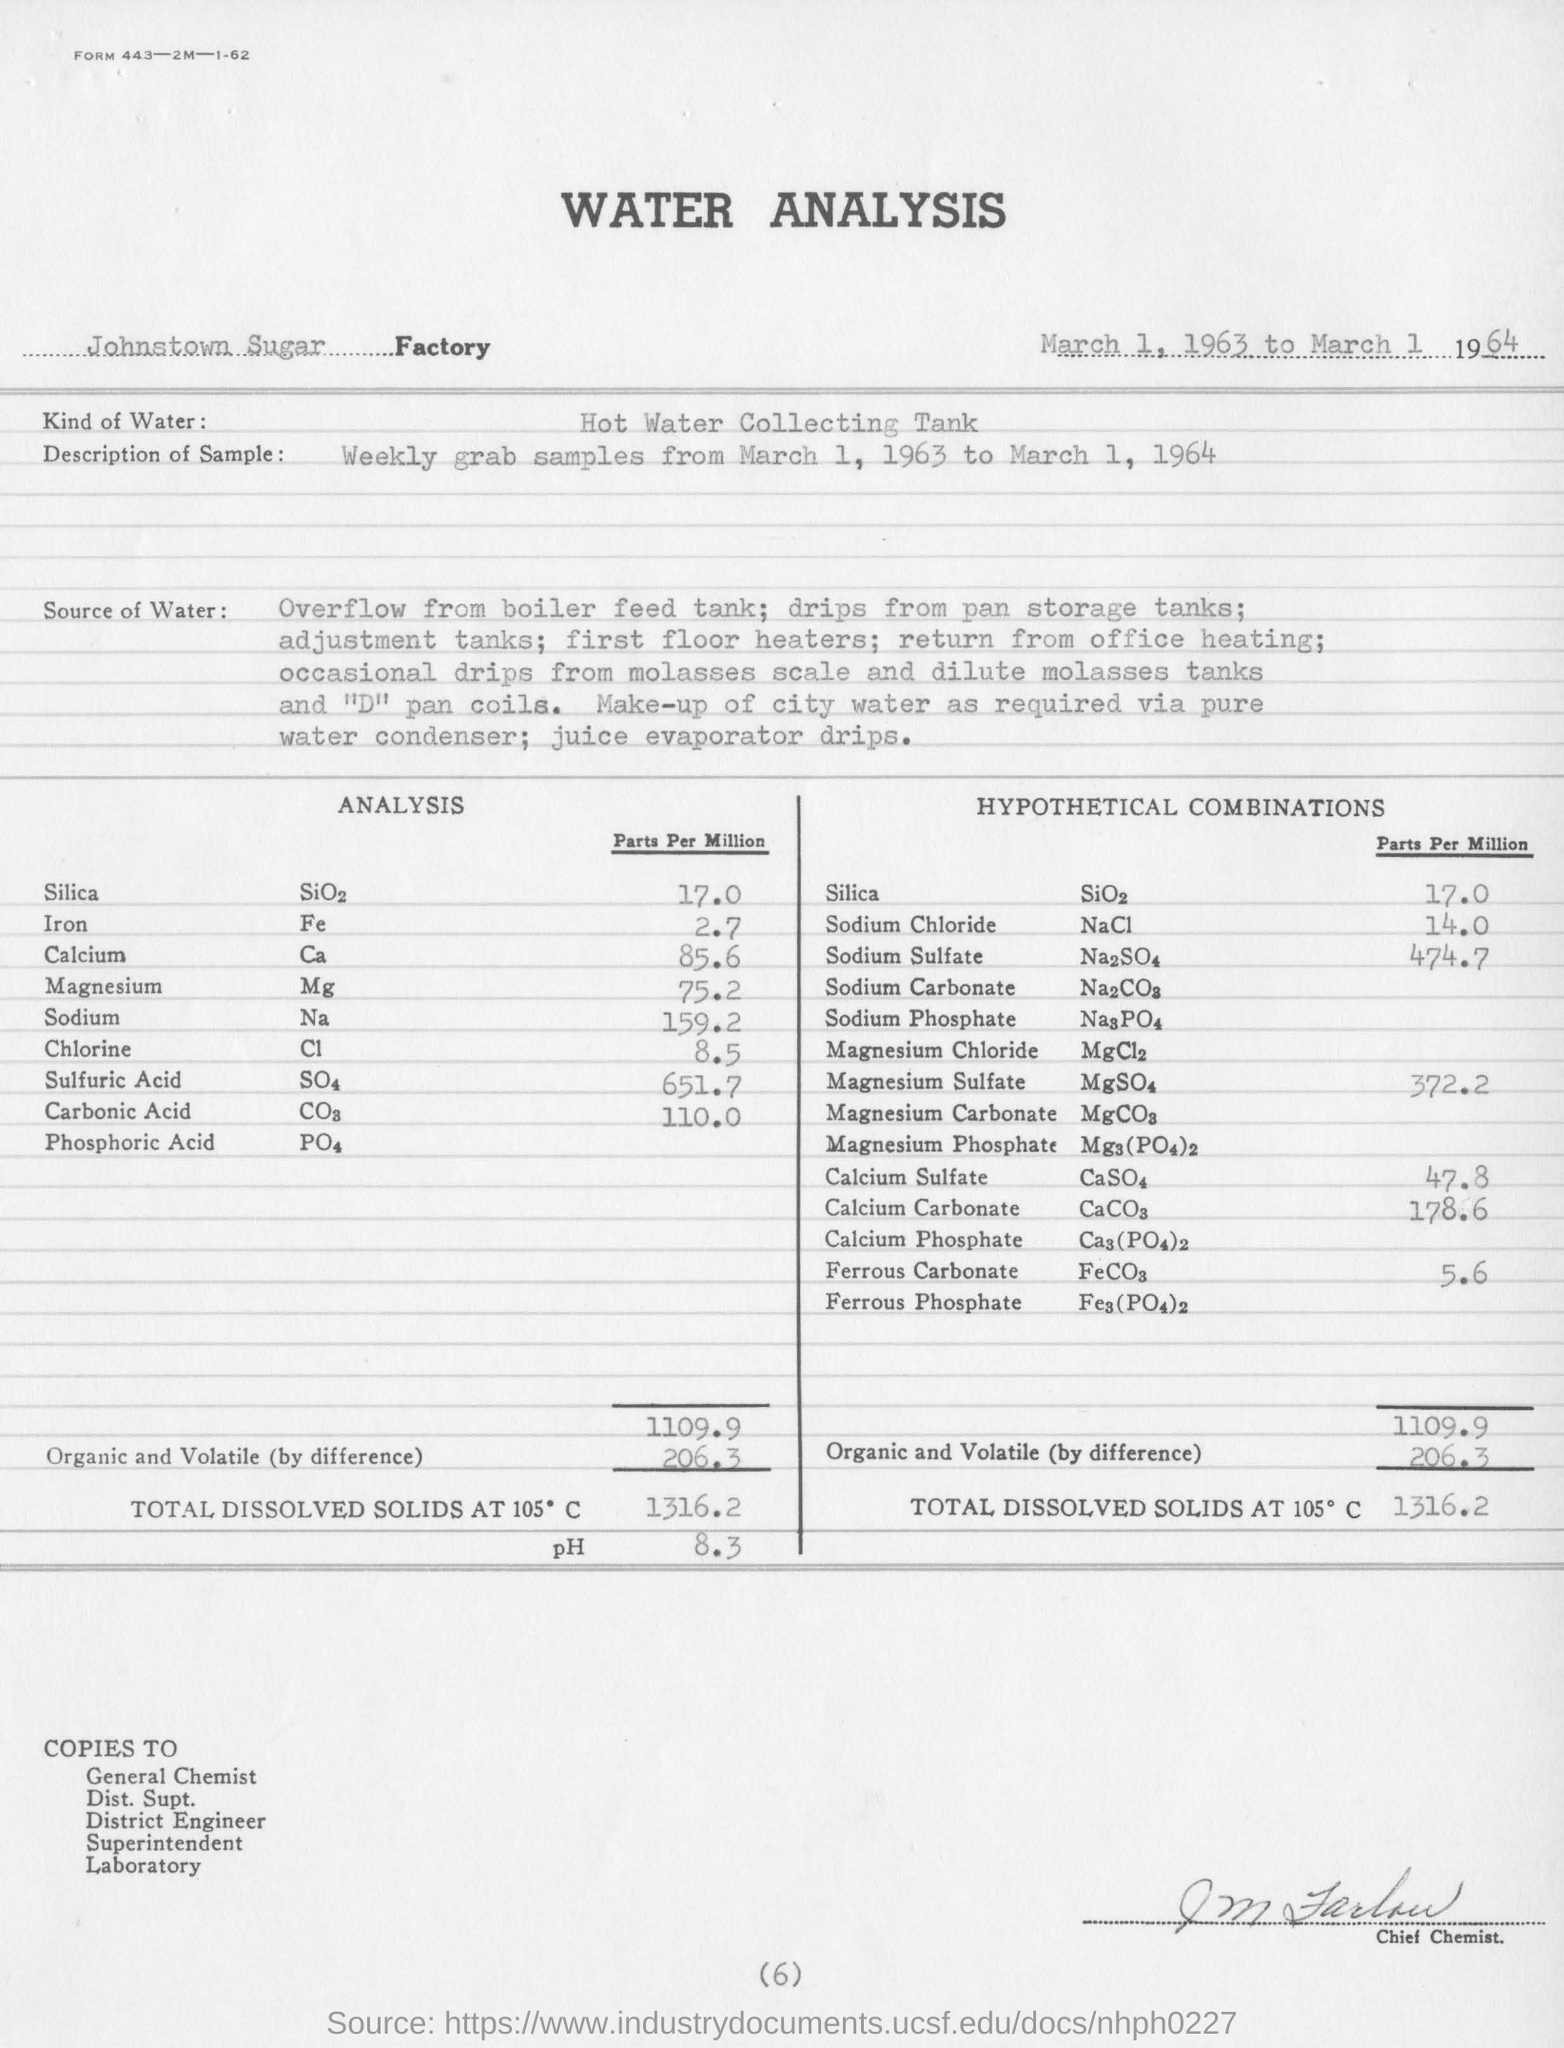What is the hypothetical combinations of silica in parts per million ?
Offer a very short reply. 17.0. What is the amount of total dissolved solids at 105 degrees c?
Your response must be concise. 1316.2. What is the ph value for the total dissolved solids ?
Make the answer very short. 8.3. What is the hypothetical combinations of calcium carbonate in parts per million ?
Your answer should be very brief. 178.6. What is the value of chlorine in parts per million ?
Offer a very short reply. 8.5. 